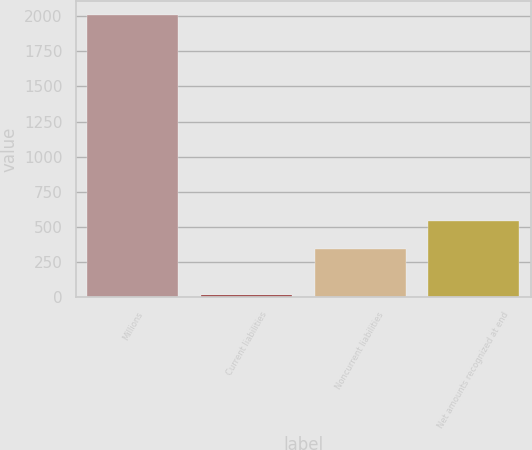<chart> <loc_0><loc_0><loc_500><loc_500><bar_chart><fcel>Millions<fcel>Current liabilities<fcel>Noncurrent liabilities<fcel>Net amounts recognized at end<nl><fcel>2010<fcel>15<fcel>341<fcel>540.5<nl></chart> 